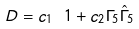Convert formula to latex. <formula><loc_0><loc_0><loc_500><loc_500>D = c _ { 1 } \ 1 + c _ { 2 } \Gamma _ { 5 } \hat { \Gamma } _ { 5 }</formula> 